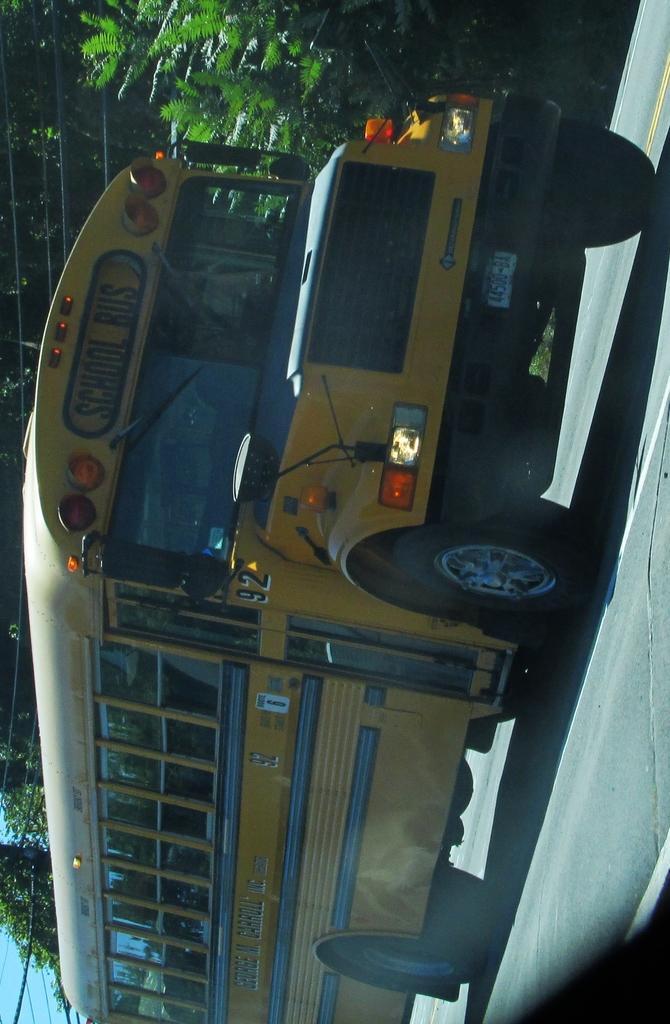Please provide a concise description of this image. In this image we can see one school bus on the road, some trees, some wires and at the top there is the sky. 